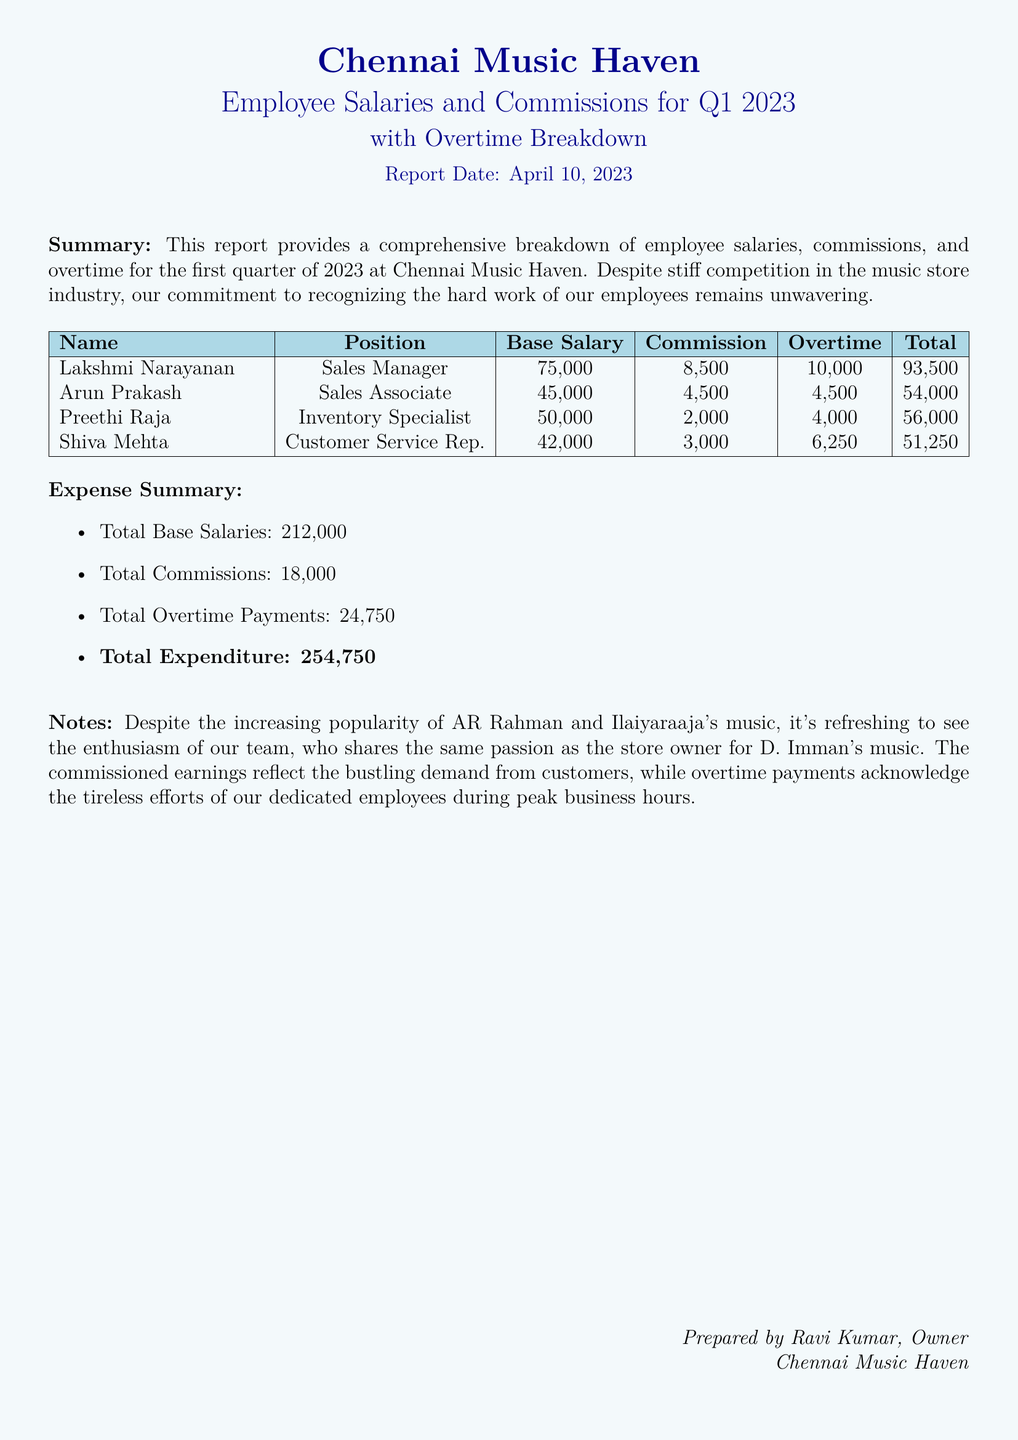What is the report date? The report date is explicitly mentioned in the document as April 10, 2023.
Answer: April 10, 2023 Who is the Sales Manager? The name of the Sales Manager is stated in the employee list portion of the report.
Answer: Lakshmi Narayanan What is the total expenditure? The total expenditure is the sum of all payroll-related expenses detailed in the expense summary.
Answer: ₹254,750 How much did the Inventory Specialist earn in total? The total earnings of the Inventory Specialist are calculated from their base salary, commission, and overtime.
Answer: ₹56,000 What is the total amount paid for commissions? The total amount for all commissions is summarized in the expense summary section.
Answer: ₹18,000 Which position has the highest overtime payment? The highest overtime payment can be determined by examining the overtime figures listed for each employee.
Answer: Sales Manager What is Arun Prakash's base salary? Arun Prakash's base salary is directly provided in the employee salary table.
Answer: ₹45,000 What color is used for the table header? The color used for the table header is specified in the document's formatting details.
Answer: Light blue 